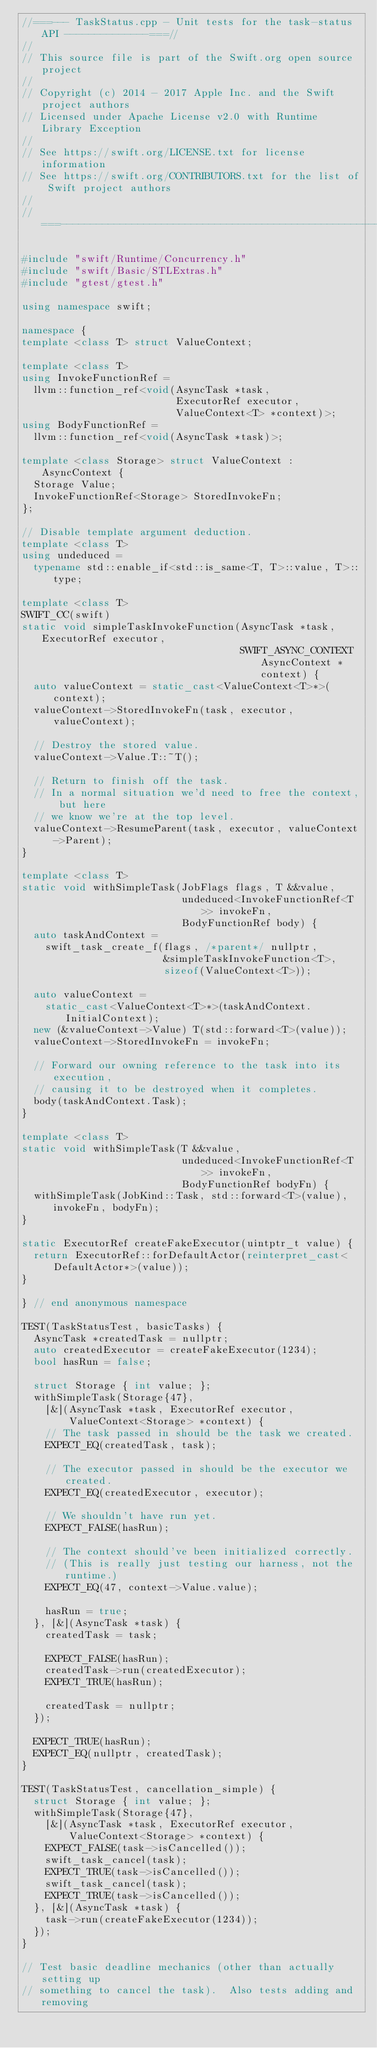<code> <loc_0><loc_0><loc_500><loc_500><_C++_>//===--- TaskStatus.cpp - Unit tests for the task-status API --------------===//
//
// This source file is part of the Swift.org open source project
//
// Copyright (c) 2014 - 2017 Apple Inc. and the Swift project authors
// Licensed under Apache License v2.0 with Runtime Library Exception
//
// See https://swift.org/LICENSE.txt for license information
// See https://swift.org/CONTRIBUTORS.txt for the list of Swift project authors
//
//===----------------------------------------------------------------------===//

#include "swift/Runtime/Concurrency.h"
#include "swift/Basic/STLExtras.h"
#include "gtest/gtest.h"

using namespace swift;

namespace {
template <class T> struct ValueContext;

template <class T>
using InvokeFunctionRef =
  llvm::function_ref<void(AsyncTask *task,
                          ExecutorRef executor,
                          ValueContext<T> *context)>;
using BodyFunctionRef =
  llvm::function_ref<void(AsyncTask *task)>;

template <class Storage> struct ValueContext : AsyncContext {
  Storage Value;
  InvokeFunctionRef<Storage> StoredInvokeFn;
};

// Disable template argument deduction.
template <class T>
using undeduced =
  typename std::enable_if<std::is_same<T, T>::value, T>::type;

template <class T>
SWIFT_CC(swift)
static void simpleTaskInvokeFunction(AsyncTask *task, ExecutorRef executor,
                                     SWIFT_ASYNC_CONTEXT AsyncContext *context) {
  auto valueContext = static_cast<ValueContext<T>*>(context);
  valueContext->StoredInvokeFn(task, executor, valueContext);

  // Destroy the stored value.
  valueContext->Value.T::~T();

  // Return to finish off the task.
  // In a normal situation we'd need to free the context, but here
  // we know we're at the top level.
  valueContext->ResumeParent(task, executor, valueContext->Parent);
}

template <class T>
static void withSimpleTask(JobFlags flags, T &&value,
                           undeduced<InvokeFunctionRef<T>> invokeFn,
                           BodyFunctionRef body) {
  auto taskAndContext =
    swift_task_create_f(flags, /*parent*/ nullptr,
                        &simpleTaskInvokeFunction<T>,
                        sizeof(ValueContext<T>));

  auto valueContext =
    static_cast<ValueContext<T>*>(taskAndContext.InitialContext);
  new (&valueContext->Value) T(std::forward<T>(value));
  valueContext->StoredInvokeFn = invokeFn;

  // Forward our owning reference to the task into its execution,
  // causing it to be destroyed when it completes.
  body(taskAndContext.Task);
}

template <class T>
static void withSimpleTask(T &&value,
                           undeduced<InvokeFunctionRef<T>> invokeFn,
                           BodyFunctionRef bodyFn) {
  withSimpleTask(JobKind::Task, std::forward<T>(value), invokeFn, bodyFn);
}

static ExecutorRef createFakeExecutor(uintptr_t value) {
  return ExecutorRef::forDefaultActor(reinterpret_cast<DefaultActor*>(value));
}

} // end anonymous namespace

TEST(TaskStatusTest, basicTasks) {
  AsyncTask *createdTask = nullptr;
  auto createdExecutor = createFakeExecutor(1234);
  bool hasRun = false;

  struct Storage { int value; };
  withSimpleTask(Storage{47},
    [&](AsyncTask *task, ExecutorRef executor,
        ValueContext<Storage> *context) {
    // The task passed in should be the task we created.
    EXPECT_EQ(createdTask, task);

    // The executor passed in should be the executor we created.
    EXPECT_EQ(createdExecutor, executor);

    // We shouldn't have run yet.
    EXPECT_FALSE(hasRun);

    // The context should've been initialized correctly.
    // (This is really just testing our harness, not the runtime.)
    EXPECT_EQ(47, context->Value.value);

    hasRun = true;
  }, [&](AsyncTask *task) {
    createdTask = task;

    EXPECT_FALSE(hasRun);
    createdTask->run(createdExecutor);
    EXPECT_TRUE(hasRun);

    createdTask = nullptr;
  });

  EXPECT_TRUE(hasRun);
  EXPECT_EQ(nullptr, createdTask);
}

TEST(TaskStatusTest, cancellation_simple) {
  struct Storage { int value; };
  withSimpleTask(Storage{47},
    [&](AsyncTask *task, ExecutorRef executor,
        ValueContext<Storage> *context) {
    EXPECT_FALSE(task->isCancelled());
    swift_task_cancel(task);
    EXPECT_TRUE(task->isCancelled());
    swift_task_cancel(task);
    EXPECT_TRUE(task->isCancelled());
  }, [&](AsyncTask *task) {
    task->run(createFakeExecutor(1234));
  });
}

// Test basic deadline mechanics (other than actually setting up
// something to cancel the task).  Also tests adding and removing</code> 